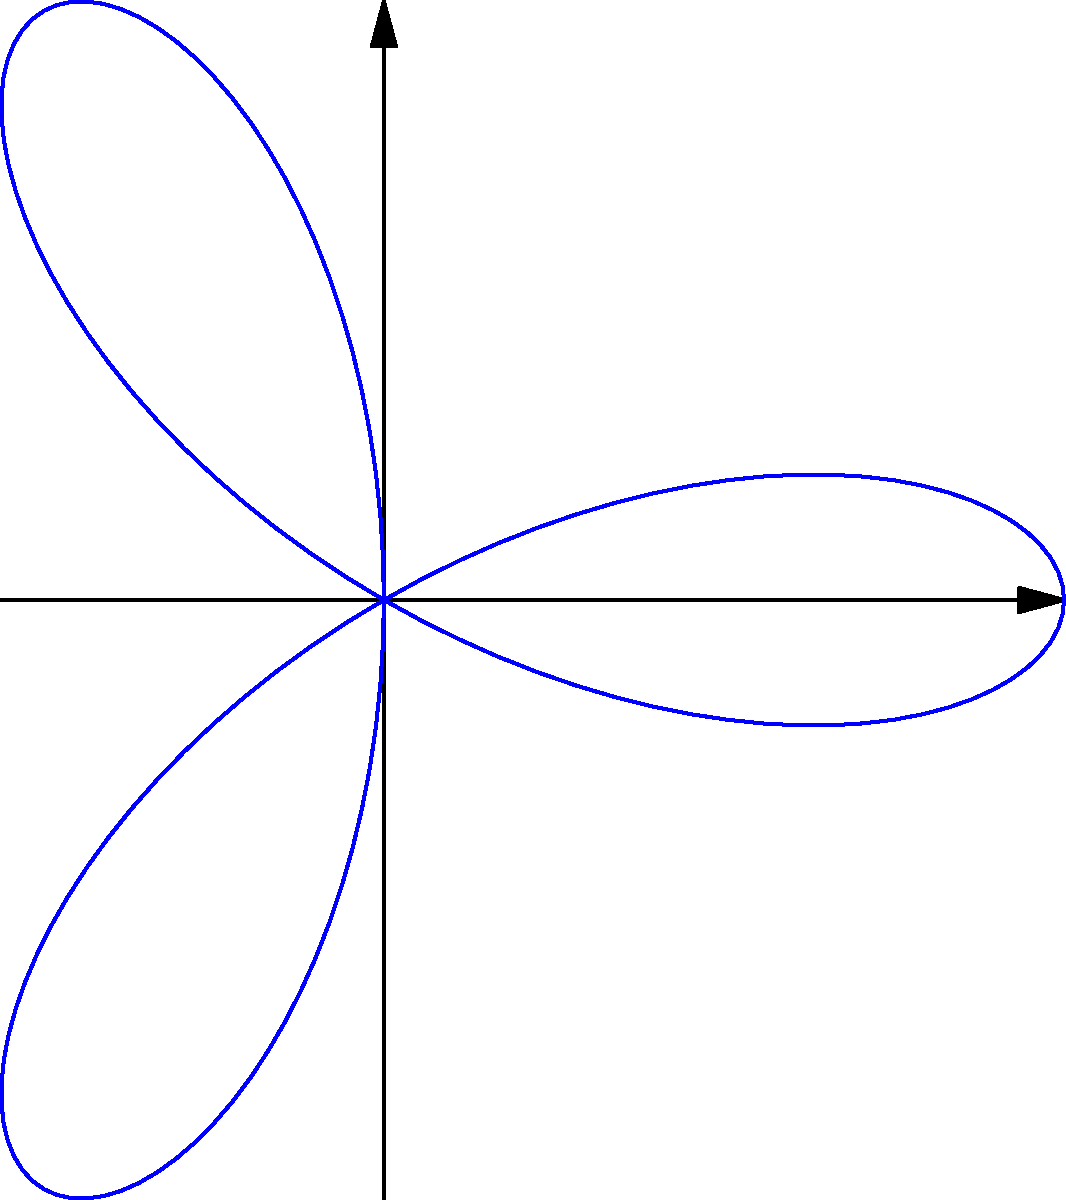Given the polar rose curve $r = 2\cos(3\theta)$, how many petals does the curve have, and what is the maximum radius of each petal? To answer this question, let's break it down into steps:

1. Number of petals:
   - The number of petals in a polar rose curve is determined by the coefficient of $\theta$ in the cosine function.
   - In this case, we have $r = 2\cos(3\theta)$.
   - The coefficient of $\theta$ is 3.
   - For $\cos(n\theta)$, if $n$ is odd, the number of petals is $n$.
   - Since 3 is odd, the curve has 3 petals.

2. Maximum radius:
   - The maximum radius occurs when the cosine function reaches its maximum value of 1.
   - In the equation $r = 2\cos(3\theta)$, the factor 2 is multiplied by the cosine term.
   - Therefore, the maximum radius is 2 units.

To verify these results visually:
   - The graph shows 3 distinct petals.
   - The petals extend 2 units from the origin at their farthest points.
Answer: 3 petals; 2 units 